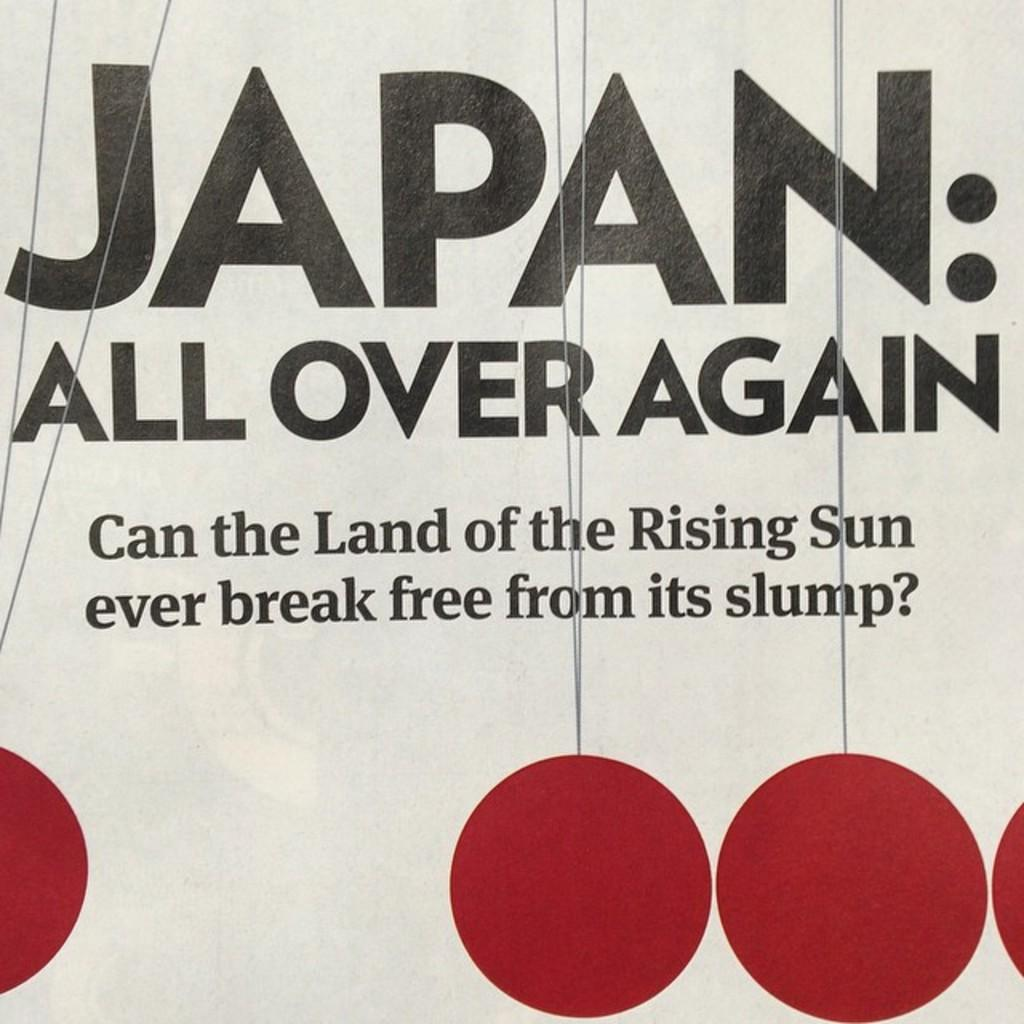What is present in the image that has a design or message? There is a poster in the image. What colors are used in the design of the poster? The poster has red color circles. What else can be found on the poster besides the circles? There is writing on the poster. What type of fiction is being advertised at the station in the image? There is no reference to fiction, apparel, or a station in the image; it only features a poster with red color circles and writing. 